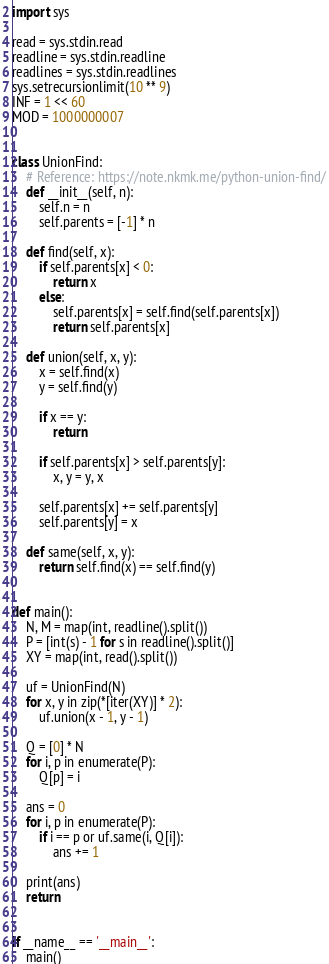Convert code to text. <code><loc_0><loc_0><loc_500><loc_500><_Python_>import sys

read = sys.stdin.read
readline = sys.stdin.readline
readlines = sys.stdin.readlines
sys.setrecursionlimit(10 ** 9)
INF = 1 << 60
MOD = 1000000007


class UnionFind:
    # Reference: https://note.nkmk.me/python-union-find/
    def __init__(self, n):
        self.n = n
        self.parents = [-1] * n

    def find(self, x):
        if self.parents[x] < 0:
            return x
        else:
            self.parents[x] = self.find(self.parents[x])
            return self.parents[x]

    def union(self, x, y):
        x = self.find(x)
        y = self.find(y)

        if x == y:
            return

        if self.parents[x] > self.parents[y]:
            x, y = y, x

        self.parents[x] += self.parents[y]
        self.parents[y] = x

    def same(self, x, y):
        return self.find(x) == self.find(y)


def main():
    N, M = map(int, readline().split())
    P = [int(s) - 1 for s in readline().split()]
    XY = map(int, read().split())

    uf = UnionFind(N)
    for x, y in zip(*[iter(XY)] * 2):
        uf.union(x - 1, y - 1)

    Q = [0] * N
    for i, p in enumerate(P):
        Q[p] = i

    ans = 0
    for i, p in enumerate(P):
        if i == p or uf.same(i, Q[i]):
            ans += 1

    print(ans)
    return


if __name__ == '__main__':
    main()
</code> 